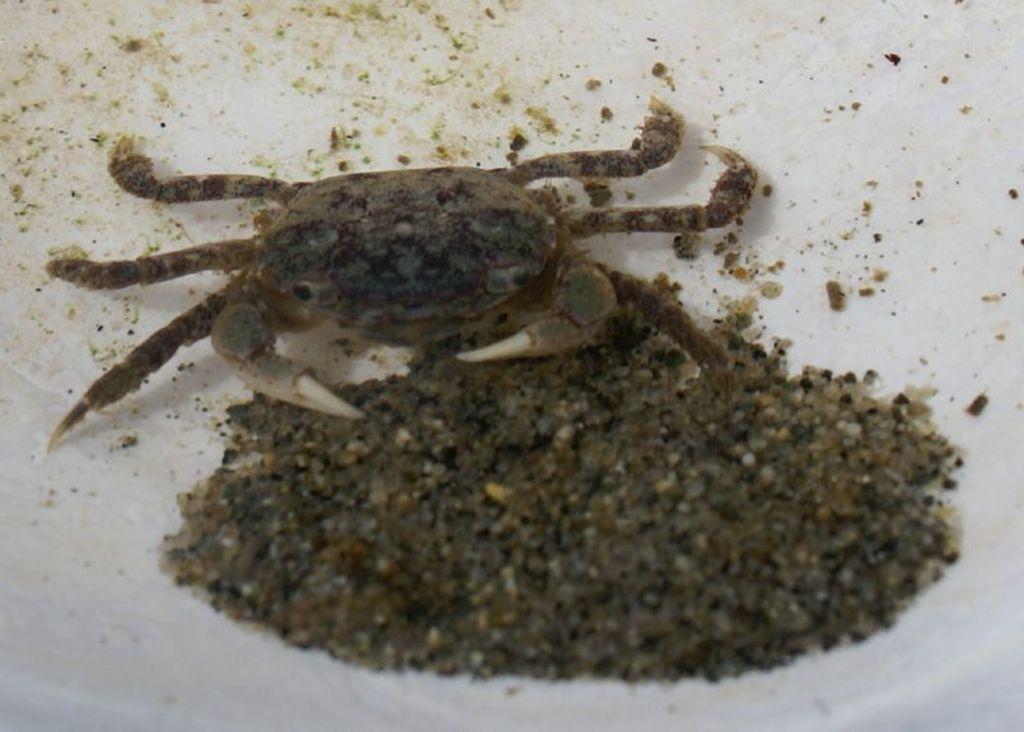What type of creature can be seen in the image? There is an insect in the image. What type of terrain or substance is visible in the image? There is mud visible in the image. What is the color of the surface on which the image is displayed? The image is on a white color surface. What type of cloth is being used to clean the cars in the image? There are no cars or cloth present in the image; it features an insect and mud. How many ladybugs can be seen in the image? There is no ladybug present in the image; it features an insect, but the specific type is not mentioned. 